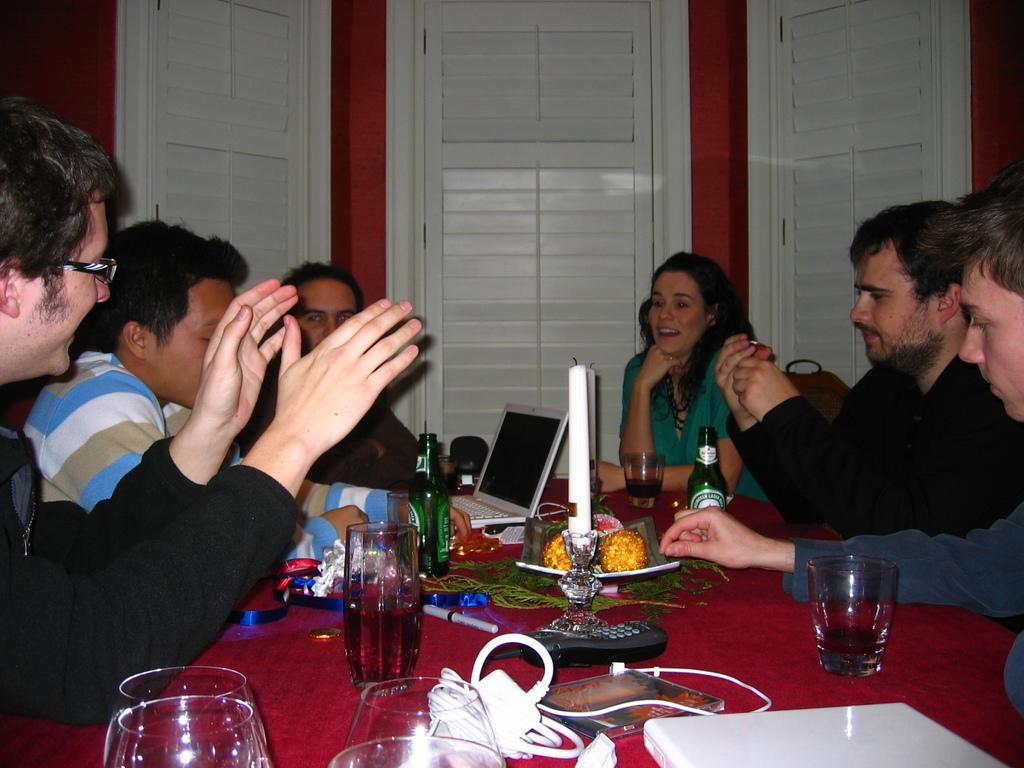Could you give a brief overview of what you see in this image? There are six members sitting around a table. There is a woman among the six, remaining five were men. On the table there is a laptop, bottle, glass and a telephone along with a candle was placed. In the background there are some doors here. 